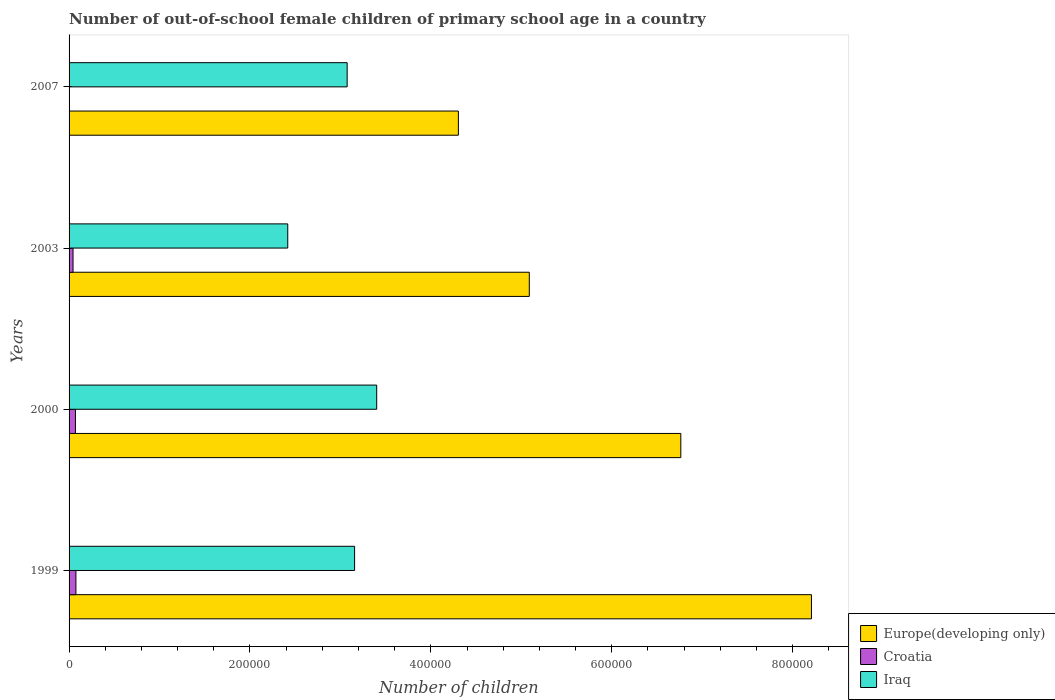How many different coloured bars are there?
Provide a succinct answer. 3. How many groups of bars are there?
Offer a very short reply. 4. Are the number of bars on each tick of the Y-axis equal?
Offer a terse response. Yes. In how many cases, is the number of bars for a given year not equal to the number of legend labels?
Offer a very short reply. 0. What is the number of out-of-school female children in Croatia in 1999?
Ensure brevity in your answer.  7567. Across all years, what is the maximum number of out-of-school female children in Croatia?
Your answer should be very brief. 7567. Across all years, what is the minimum number of out-of-school female children in Croatia?
Ensure brevity in your answer.  109. In which year was the number of out-of-school female children in Croatia maximum?
Offer a very short reply. 1999. What is the total number of out-of-school female children in Iraq in the graph?
Offer a terse response. 1.20e+06. What is the difference between the number of out-of-school female children in Croatia in 2000 and that in 2007?
Provide a short and direct response. 6944. What is the difference between the number of out-of-school female children in Europe(developing only) in 2000 and the number of out-of-school female children in Iraq in 2003?
Offer a terse response. 4.35e+05. What is the average number of out-of-school female children in Iraq per year?
Keep it short and to the point. 3.01e+05. In the year 2007, what is the difference between the number of out-of-school female children in Iraq and number of out-of-school female children in Croatia?
Keep it short and to the point. 3.07e+05. In how many years, is the number of out-of-school female children in Iraq greater than 480000 ?
Give a very brief answer. 0. What is the ratio of the number of out-of-school female children in Europe(developing only) in 2000 to that in 2007?
Your answer should be very brief. 1.57. Is the number of out-of-school female children in Europe(developing only) in 1999 less than that in 2000?
Keep it short and to the point. No. Is the difference between the number of out-of-school female children in Iraq in 2000 and 2007 greater than the difference between the number of out-of-school female children in Croatia in 2000 and 2007?
Keep it short and to the point. Yes. What is the difference between the highest and the second highest number of out-of-school female children in Croatia?
Your answer should be very brief. 514. What is the difference between the highest and the lowest number of out-of-school female children in Croatia?
Make the answer very short. 7458. What does the 1st bar from the top in 1999 represents?
Provide a short and direct response. Iraq. What does the 3rd bar from the bottom in 2007 represents?
Provide a succinct answer. Iraq. Is it the case that in every year, the sum of the number of out-of-school female children in Europe(developing only) and number of out-of-school female children in Iraq is greater than the number of out-of-school female children in Croatia?
Offer a very short reply. Yes. How many bars are there?
Offer a terse response. 12. What is the difference between two consecutive major ticks on the X-axis?
Provide a short and direct response. 2.00e+05. Are the values on the major ticks of X-axis written in scientific E-notation?
Your answer should be compact. No. Does the graph contain any zero values?
Your response must be concise. No. How are the legend labels stacked?
Provide a short and direct response. Vertical. What is the title of the graph?
Ensure brevity in your answer.  Number of out-of-school female children of primary school age in a country. What is the label or title of the X-axis?
Ensure brevity in your answer.  Number of children. What is the label or title of the Y-axis?
Offer a very short reply. Years. What is the Number of children in Europe(developing only) in 1999?
Keep it short and to the point. 8.21e+05. What is the Number of children in Croatia in 1999?
Provide a short and direct response. 7567. What is the Number of children of Iraq in 1999?
Provide a short and direct response. 3.16e+05. What is the Number of children in Europe(developing only) in 2000?
Provide a succinct answer. 6.76e+05. What is the Number of children in Croatia in 2000?
Provide a succinct answer. 7053. What is the Number of children of Iraq in 2000?
Keep it short and to the point. 3.40e+05. What is the Number of children of Europe(developing only) in 2003?
Your answer should be very brief. 5.09e+05. What is the Number of children in Croatia in 2003?
Keep it short and to the point. 4375. What is the Number of children in Iraq in 2003?
Your answer should be compact. 2.42e+05. What is the Number of children of Europe(developing only) in 2007?
Make the answer very short. 4.30e+05. What is the Number of children of Croatia in 2007?
Offer a terse response. 109. What is the Number of children of Iraq in 2007?
Provide a succinct answer. 3.07e+05. Across all years, what is the maximum Number of children in Europe(developing only)?
Provide a succinct answer. 8.21e+05. Across all years, what is the maximum Number of children of Croatia?
Your answer should be compact. 7567. Across all years, what is the maximum Number of children in Iraq?
Your answer should be very brief. 3.40e+05. Across all years, what is the minimum Number of children in Europe(developing only)?
Your answer should be compact. 4.30e+05. Across all years, what is the minimum Number of children in Croatia?
Offer a terse response. 109. Across all years, what is the minimum Number of children of Iraq?
Provide a short and direct response. 2.42e+05. What is the total Number of children of Europe(developing only) in the graph?
Give a very brief answer. 2.44e+06. What is the total Number of children in Croatia in the graph?
Make the answer very short. 1.91e+04. What is the total Number of children in Iraq in the graph?
Provide a short and direct response. 1.20e+06. What is the difference between the Number of children of Europe(developing only) in 1999 and that in 2000?
Give a very brief answer. 1.44e+05. What is the difference between the Number of children of Croatia in 1999 and that in 2000?
Keep it short and to the point. 514. What is the difference between the Number of children in Iraq in 1999 and that in 2000?
Provide a succinct answer. -2.45e+04. What is the difference between the Number of children in Europe(developing only) in 1999 and that in 2003?
Your response must be concise. 3.12e+05. What is the difference between the Number of children of Croatia in 1999 and that in 2003?
Make the answer very short. 3192. What is the difference between the Number of children in Iraq in 1999 and that in 2003?
Provide a succinct answer. 7.39e+04. What is the difference between the Number of children of Europe(developing only) in 1999 and that in 2007?
Your answer should be very brief. 3.90e+05. What is the difference between the Number of children in Croatia in 1999 and that in 2007?
Keep it short and to the point. 7458. What is the difference between the Number of children in Iraq in 1999 and that in 2007?
Ensure brevity in your answer.  8220. What is the difference between the Number of children in Europe(developing only) in 2000 and that in 2003?
Offer a terse response. 1.68e+05. What is the difference between the Number of children in Croatia in 2000 and that in 2003?
Provide a succinct answer. 2678. What is the difference between the Number of children in Iraq in 2000 and that in 2003?
Offer a very short reply. 9.84e+04. What is the difference between the Number of children in Europe(developing only) in 2000 and that in 2007?
Your response must be concise. 2.46e+05. What is the difference between the Number of children in Croatia in 2000 and that in 2007?
Provide a short and direct response. 6944. What is the difference between the Number of children of Iraq in 2000 and that in 2007?
Ensure brevity in your answer.  3.27e+04. What is the difference between the Number of children of Europe(developing only) in 2003 and that in 2007?
Your answer should be compact. 7.84e+04. What is the difference between the Number of children of Croatia in 2003 and that in 2007?
Your answer should be compact. 4266. What is the difference between the Number of children in Iraq in 2003 and that in 2007?
Offer a very short reply. -6.57e+04. What is the difference between the Number of children in Europe(developing only) in 1999 and the Number of children in Croatia in 2000?
Offer a terse response. 8.14e+05. What is the difference between the Number of children in Europe(developing only) in 1999 and the Number of children in Iraq in 2000?
Offer a very short reply. 4.81e+05. What is the difference between the Number of children in Croatia in 1999 and the Number of children in Iraq in 2000?
Give a very brief answer. -3.33e+05. What is the difference between the Number of children in Europe(developing only) in 1999 and the Number of children in Croatia in 2003?
Make the answer very short. 8.16e+05. What is the difference between the Number of children of Europe(developing only) in 1999 and the Number of children of Iraq in 2003?
Keep it short and to the point. 5.79e+05. What is the difference between the Number of children in Croatia in 1999 and the Number of children in Iraq in 2003?
Keep it short and to the point. -2.34e+05. What is the difference between the Number of children in Europe(developing only) in 1999 and the Number of children in Croatia in 2007?
Your answer should be compact. 8.21e+05. What is the difference between the Number of children in Europe(developing only) in 1999 and the Number of children in Iraq in 2007?
Your answer should be very brief. 5.13e+05. What is the difference between the Number of children of Croatia in 1999 and the Number of children of Iraq in 2007?
Make the answer very short. -3.00e+05. What is the difference between the Number of children of Europe(developing only) in 2000 and the Number of children of Croatia in 2003?
Make the answer very short. 6.72e+05. What is the difference between the Number of children in Europe(developing only) in 2000 and the Number of children in Iraq in 2003?
Provide a succinct answer. 4.35e+05. What is the difference between the Number of children in Croatia in 2000 and the Number of children in Iraq in 2003?
Make the answer very short. -2.35e+05. What is the difference between the Number of children of Europe(developing only) in 2000 and the Number of children of Croatia in 2007?
Your answer should be compact. 6.76e+05. What is the difference between the Number of children in Europe(developing only) in 2000 and the Number of children in Iraq in 2007?
Your response must be concise. 3.69e+05. What is the difference between the Number of children of Croatia in 2000 and the Number of children of Iraq in 2007?
Offer a terse response. -3.00e+05. What is the difference between the Number of children in Europe(developing only) in 2003 and the Number of children in Croatia in 2007?
Your answer should be compact. 5.09e+05. What is the difference between the Number of children in Europe(developing only) in 2003 and the Number of children in Iraq in 2007?
Provide a succinct answer. 2.01e+05. What is the difference between the Number of children of Croatia in 2003 and the Number of children of Iraq in 2007?
Your answer should be compact. -3.03e+05. What is the average Number of children in Europe(developing only) per year?
Keep it short and to the point. 6.09e+05. What is the average Number of children of Croatia per year?
Your response must be concise. 4776. What is the average Number of children of Iraq per year?
Offer a very short reply. 3.01e+05. In the year 1999, what is the difference between the Number of children of Europe(developing only) and Number of children of Croatia?
Your response must be concise. 8.13e+05. In the year 1999, what is the difference between the Number of children of Europe(developing only) and Number of children of Iraq?
Provide a short and direct response. 5.05e+05. In the year 1999, what is the difference between the Number of children of Croatia and Number of children of Iraq?
Offer a very short reply. -3.08e+05. In the year 2000, what is the difference between the Number of children in Europe(developing only) and Number of children in Croatia?
Ensure brevity in your answer.  6.69e+05. In the year 2000, what is the difference between the Number of children of Europe(developing only) and Number of children of Iraq?
Ensure brevity in your answer.  3.36e+05. In the year 2000, what is the difference between the Number of children in Croatia and Number of children in Iraq?
Your answer should be very brief. -3.33e+05. In the year 2003, what is the difference between the Number of children in Europe(developing only) and Number of children in Croatia?
Your answer should be very brief. 5.04e+05. In the year 2003, what is the difference between the Number of children in Europe(developing only) and Number of children in Iraq?
Make the answer very short. 2.67e+05. In the year 2003, what is the difference between the Number of children in Croatia and Number of children in Iraq?
Give a very brief answer. -2.37e+05. In the year 2007, what is the difference between the Number of children of Europe(developing only) and Number of children of Croatia?
Offer a very short reply. 4.30e+05. In the year 2007, what is the difference between the Number of children of Europe(developing only) and Number of children of Iraq?
Keep it short and to the point. 1.23e+05. In the year 2007, what is the difference between the Number of children of Croatia and Number of children of Iraq?
Your answer should be very brief. -3.07e+05. What is the ratio of the Number of children of Europe(developing only) in 1999 to that in 2000?
Ensure brevity in your answer.  1.21. What is the ratio of the Number of children in Croatia in 1999 to that in 2000?
Give a very brief answer. 1.07. What is the ratio of the Number of children in Iraq in 1999 to that in 2000?
Give a very brief answer. 0.93. What is the ratio of the Number of children of Europe(developing only) in 1999 to that in 2003?
Your response must be concise. 1.61. What is the ratio of the Number of children in Croatia in 1999 to that in 2003?
Your answer should be compact. 1.73. What is the ratio of the Number of children of Iraq in 1999 to that in 2003?
Keep it short and to the point. 1.31. What is the ratio of the Number of children of Europe(developing only) in 1999 to that in 2007?
Make the answer very short. 1.91. What is the ratio of the Number of children of Croatia in 1999 to that in 2007?
Keep it short and to the point. 69.42. What is the ratio of the Number of children of Iraq in 1999 to that in 2007?
Provide a succinct answer. 1.03. What is the ratio of the Number of children of Europe(developing only) in 2000 to that in 2003?
Your response must be concise. 1.33. What is the ratio of the Number of children of Croatia in 2000 to that in 2003?
Your response must be concise. 1.61. What is the ratio of the Number of children in Iraq in 2000 to that in 2003?
Offer a very short reply. 1.41. What is the ratio of the Number of children in Europe(developing only) in 2000 to that in 2007?
Keep it short and to the point. 1.57. What is the ratio of the Number of children of Croatia in 2000 to that in 2007?
Keep it short and to the point. 64.71. What is the ratio of the Number of children in Iraq in 2000 to that in 2007?
Give a very brief answer. 1.11. What is the ratio of the Number of children in Europe(developing only) in 2003 to that in 2007?
Ensure brevity in your answer.  1.18. What is the ratio of the Number of children in Croatia in 2003 to that in 2007?
Provide a succinct answer. 40.14. What is the ratio of the Number of children in Iraq in 2003 to that in 2007?
Provide a short and direct response. 0.79. What is the difference between the highest and the second highest Number of children in Europe(developing only)?
Make the answer very short. 1.44e+05. What is the difference between the highest and the second highest Number of children of Croatia?
Provide a succinct answer. 514. What is the difference between the highest and the second highest Number of children of Iraq?
Provide a succinct answer. 2.45e+04. What is the difference between the highest and the lowest Number of children of Europe(developing only)?
Your answer should be very brief. 3.90e+05. What is the difference between the highest and the lowest Number of children in Croatia?
Ensure brevity in your answer.  7458. What is the difference between the highest and the lowest Number of children of Iraq?
Provide a succinct answer. 9.84e+04. 